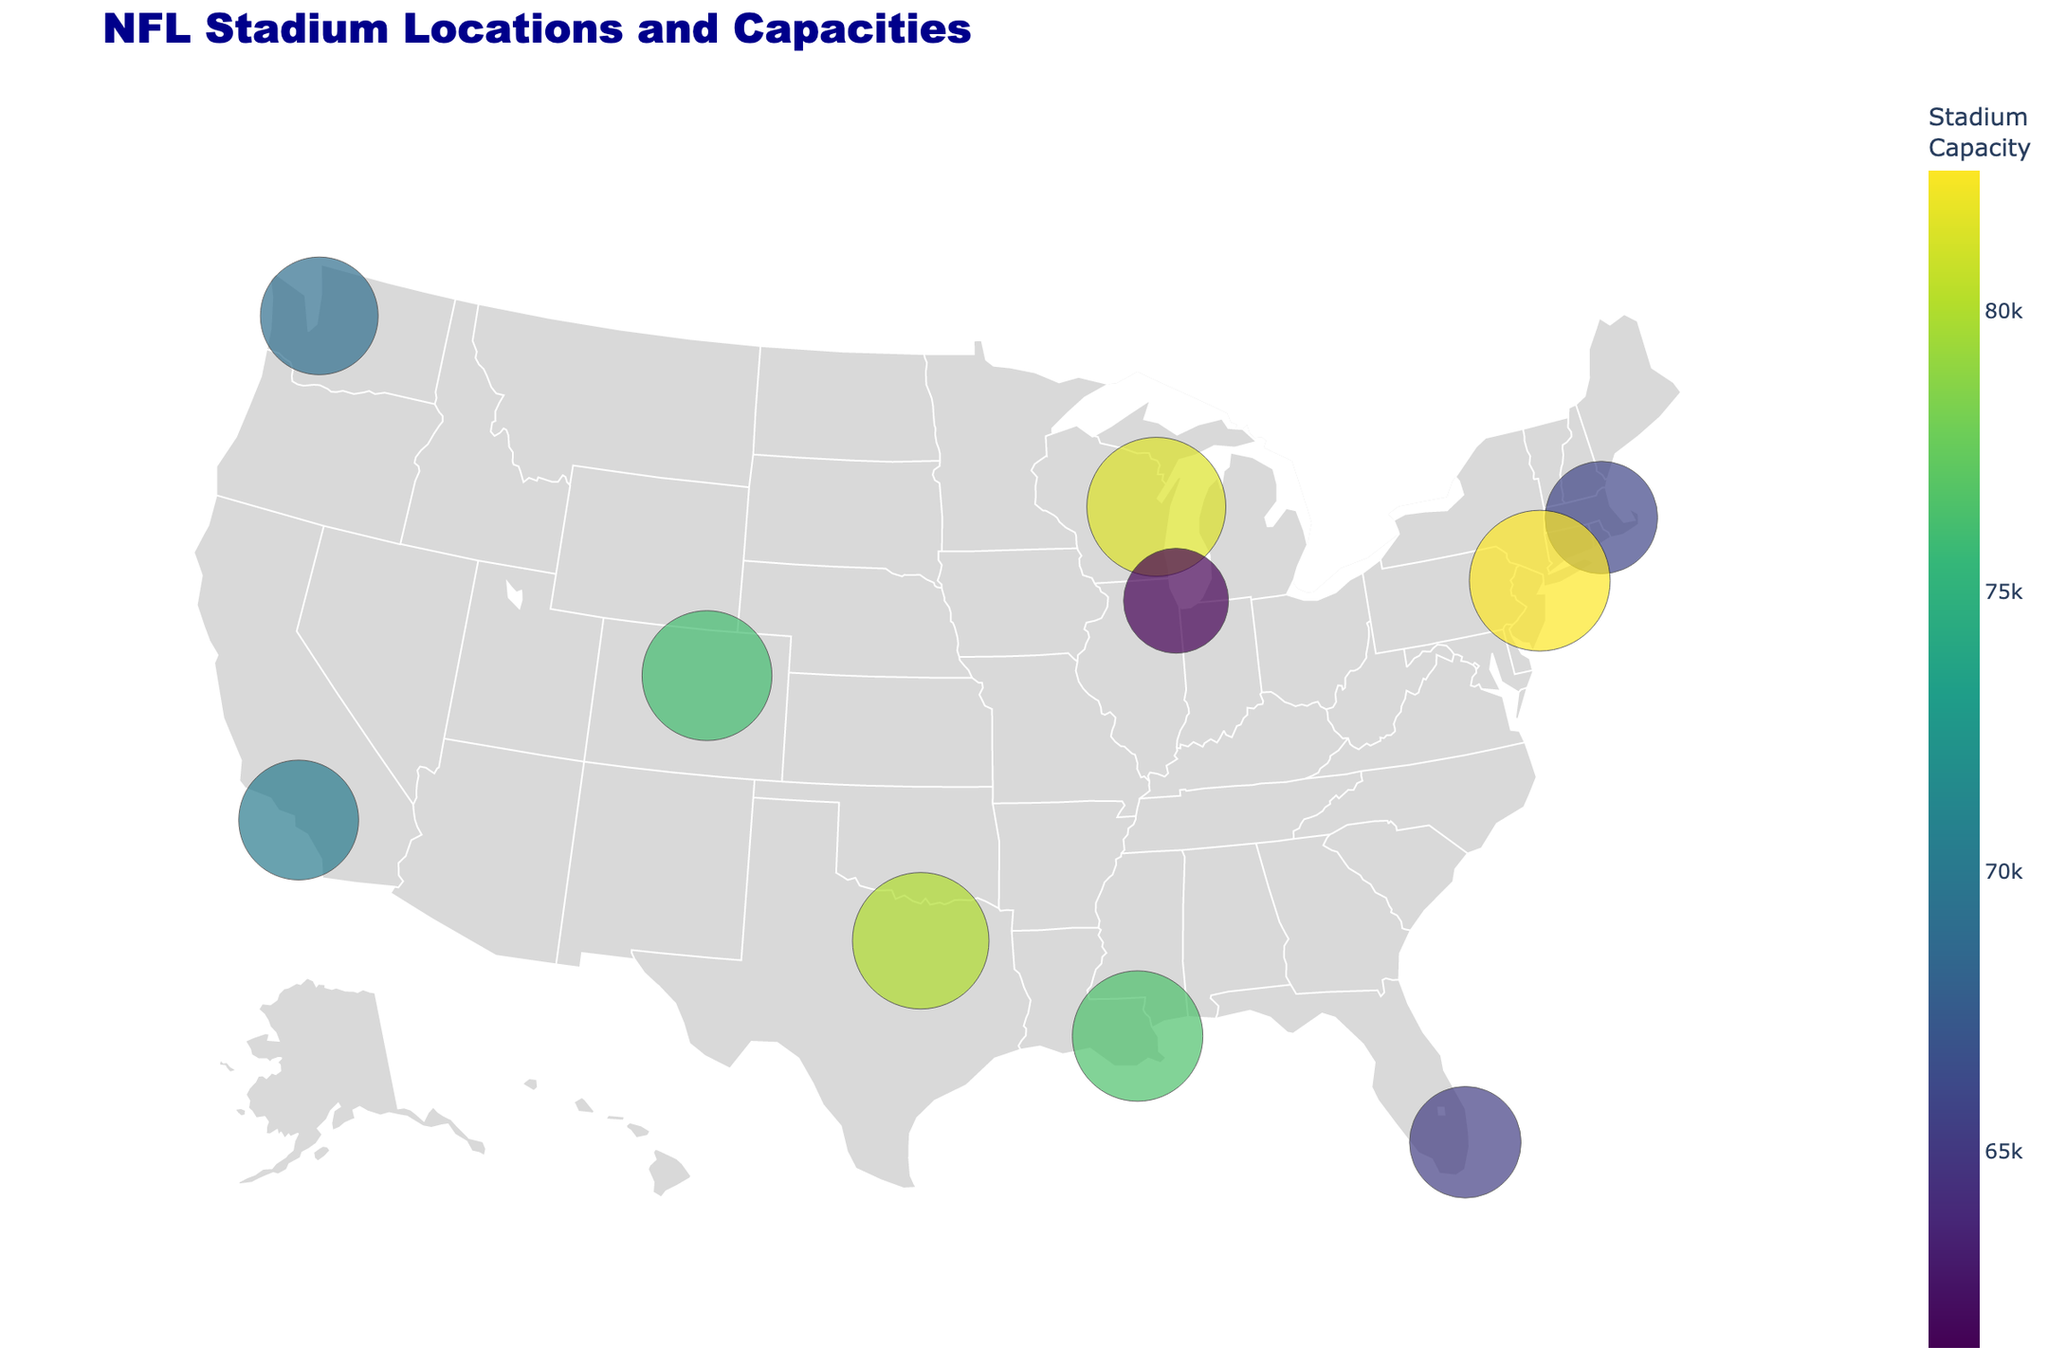What is the title of the plot? The title is displayed prominently at the top of the plot, providing an overview of what the plot represents.
Answer: NFL Stadium Locations and Capacities How many stadiums are shown on the map? Count the number of markers on the geographic plot, each representing an NFL stadium.
Answer: 10 Which stadium has the highest seating capacity? The color scale and marker size indicate the seating capacities. Find the largest marker with the darkest shade (indicating highest capacity).
Answer: MetLife Stadium Which stadium is located furthest to the west? Identify the marker on the leftmost (westernmost) side of the plot.
Answer: Lumen Field What is the seating capacity of the stadium in Arlington, Texas? Hover over or refer to the text associated with the marker at the coordinates corresponding to Arlington, Texas.
Answer: 80,000 Compare the seating capacities of Gillette Stadium and Soldier Field. Which one is larger and by how much? Find the capacities of Gillette Stadium and Soldier Field, then subtract the smaller capacity from the larger one. Gillette Stadium (65,878) - Soldier Field (61,500) = 4,378.
Answer: Gillette Stadium by 4,378 Which states have more than one NFL stadium represented in this plot? Look for repeated state names in the city locations for the markers.
Answer: None What is the average seating capacity of the stadiums shown? Sum all the seating capacities and divide by the number of stadiums. (65,878 + 80,000 + 81,441 + 82,500 + 70,240 + 61,500 + 65,326 + 76,125 + 69,000 + 76,468) / 10 = 74,948
Answer: 74,948 Which stadium has the smallest seating capacity, and where is it located? Identify the smallest marker with the lightest shade on the plot and check its associated text.
Answer: Soldier Field, Chicago, Illinois How is the seating capacity represented visually in the plot? Explain the visual elements (marker size and color scale) used to indicate seating capacity.
Answer: By marker size and color scale 